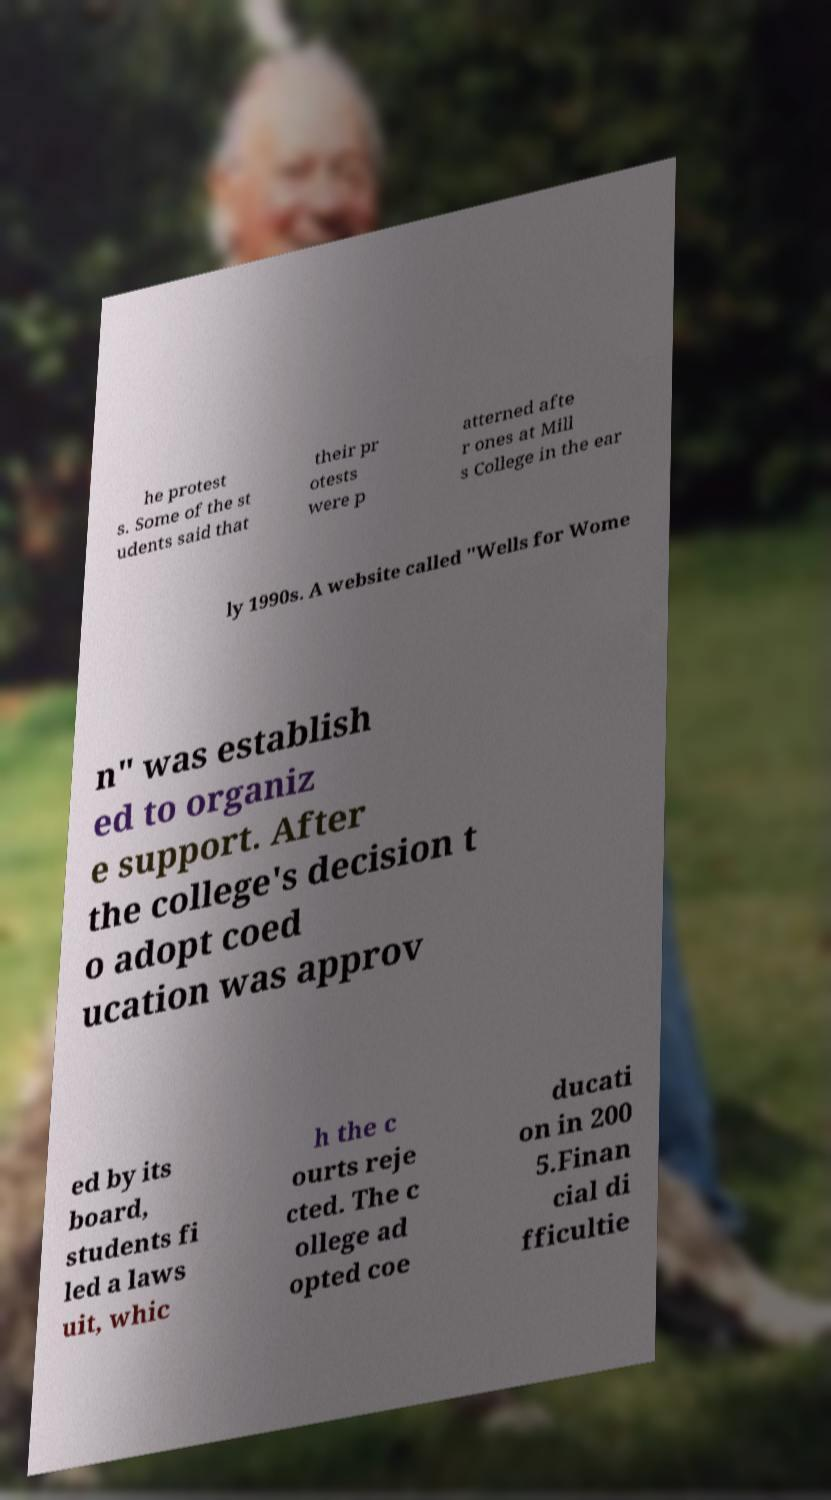Can you read and provide the text displayed in the image?This photo seems to have some interesting text. Can you extract and type it out for me? he protest s. Some of the st udents said that their pr otests were p atterned afte r ones at Mill s College in the ear ly 1990s. A website called "Wells for Wome n" was establish ed to organiz e support. After the college's decision t o adopt coed ucation was approv ed by its board, students fi led a laws uit, whic h the c ourts reje cted. The c ollege ad opted coe ducati on in 200 5.Finan cial di fficultie 